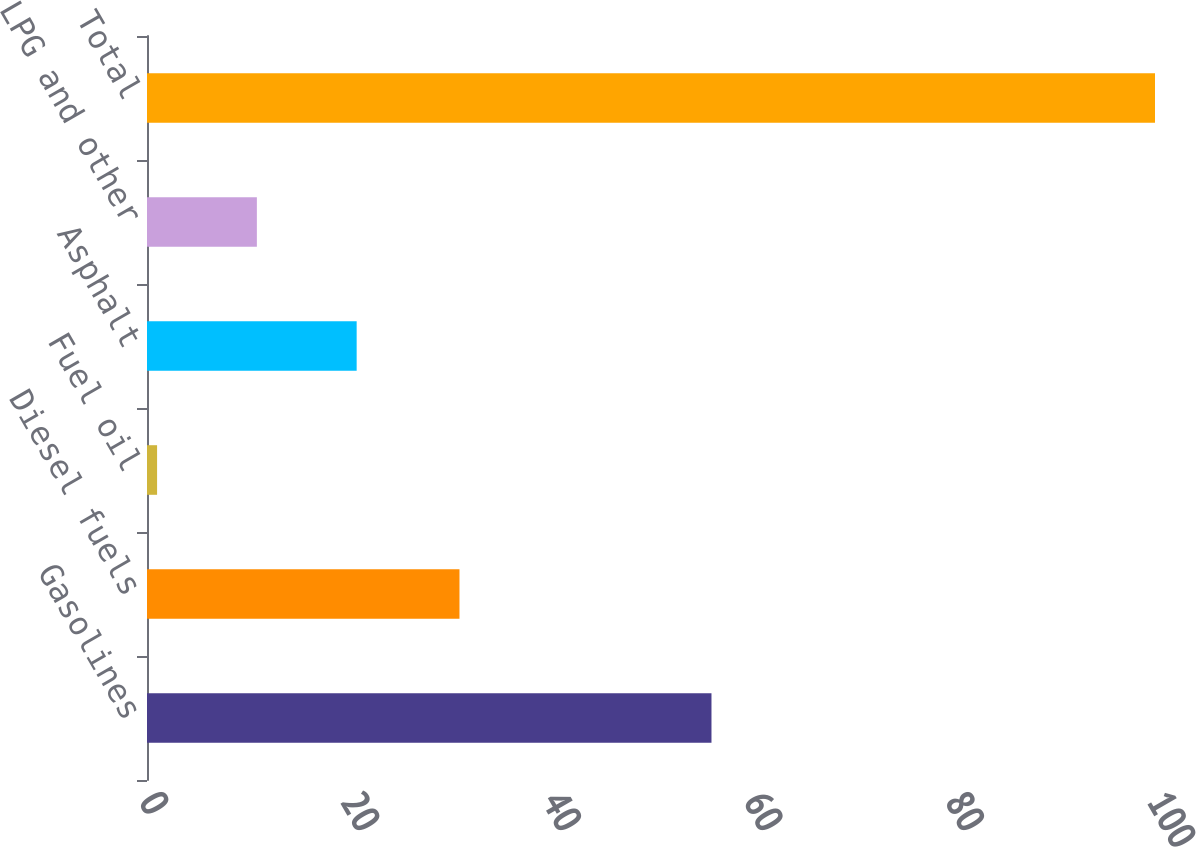<chart> <loc_0><loc_0><loc_500><loc_500><bar_chart><fcel>Gasolines<fcel>Diesel fuels<fcel>Fuel oil<fcel>Asphalt<fcel>LPG and other<fcel>Total<nl><fcel>56<fcel>31<fcel>1<fcel>20.8<fcel>10.9<fcel>100<nl></chart> 